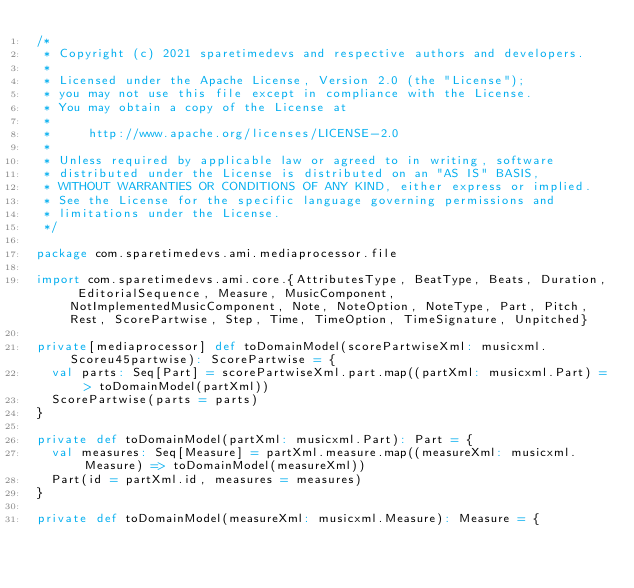Convert code to text. <code><loc_0><loc_0><loc_500><loc_500><_Scala_>/*
 * Copyright (c) 2021 sparetimedevs and respective authors and developers.
 *
 * Licensed under the Apache License, Version 2.0 (the "License");
 * you may not use this file except in compliance with the License.
 * You may obtain a copy of the License at
 *
 *     http://www.apache.org/licenses/LICENSE-2.0
 *
 * Unless required by applicable law or agreed to in writing, software
 * distributed under the License is distributed on an "AS IS" BASIS,
 * WITHOUT WARRANTIES OR CONDITIONS OF ANY KIND, either express or implied.
 * See the License for the specific language governing permissions and
 * limitations under the License.
 */

package com.sparetimedevs.ami.mediaprocessor.file

import com.sparetimedevs.ami.core.{AttributesType, BeatType, Beats, Duration, EditorialSequence, Measure, MusicComponent, NotImplementedMusicComponent, Note, NoteOption, NoteType, Part, Pitch, Rest, ScorePartwise, Step, Time, TimeOption, TimeSignature, Unpitched}

private[mediaprocessor] def toDomainModel(scorePartwiseXml: musicxml.Scoreu45partwise): ScorePartwise = {
  val parts: Seq[Part] = scorePartwiseXml.part.map((partXml: musicxml.Part) => toDomainModel(partXml))
  ScorePartwise(parts = parts)
}

private def toDomainModel(partXml: musicxml.Part): Part = {
  val measures: Seq[Measure] = partXml.measure.map((measureXml: musicxml.Measure) => toDomainModel(measureXml))
  Part(id = partXml.id, measures = measures)
}

private def toDomainModel(measureXml: musicxml.Measure): Measure = {</code> 